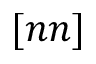Convert formula to latex. <formula><loc_0><loc_0><loc_500><loc_500>[ n n ]</formula> 